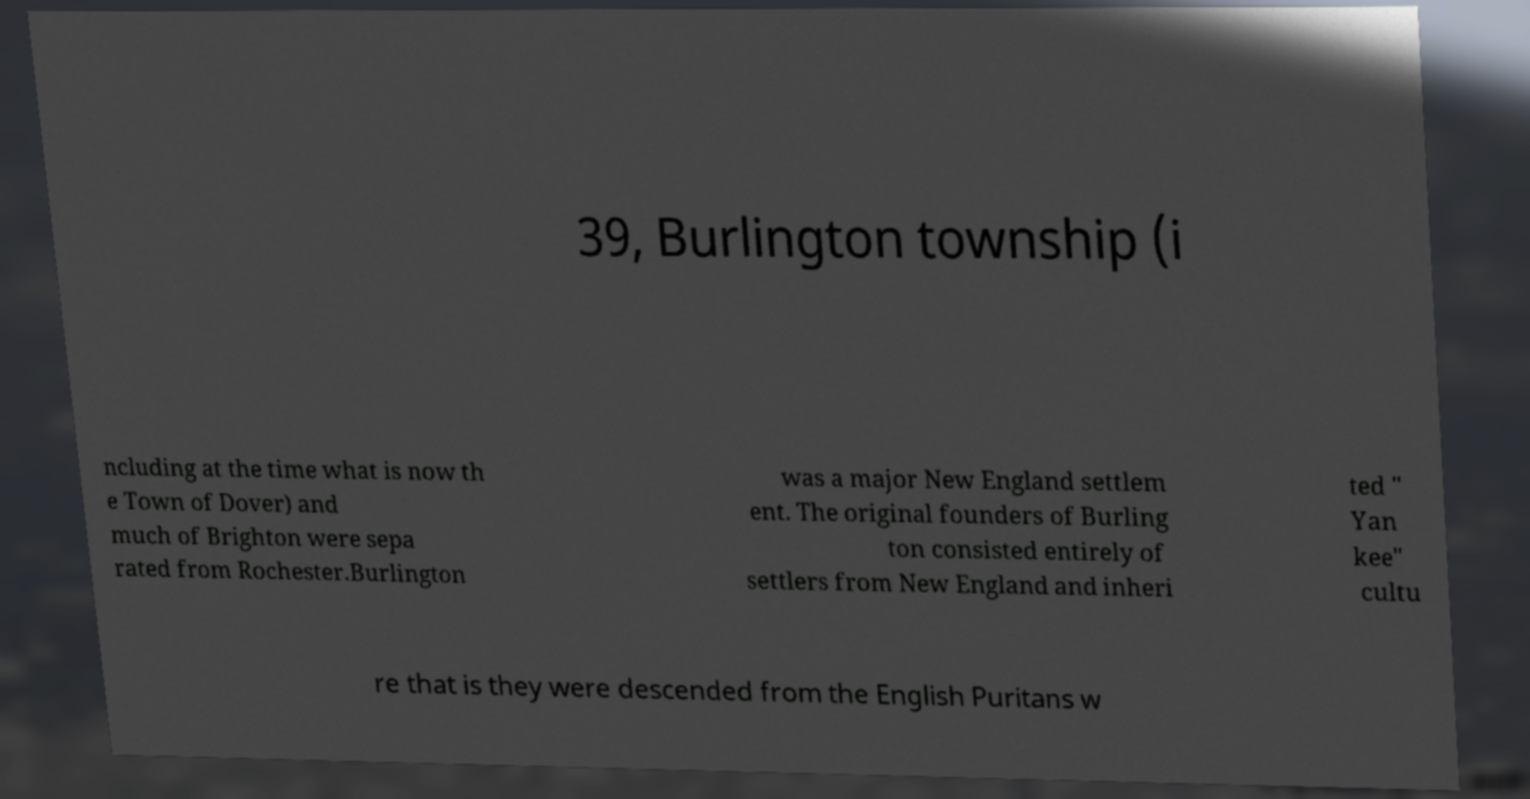Can you accurately transcribe the text from the provided image for me? 39, Burlington township (i ncluding at the time what is now th e Town of Dover) and much of Brighton were sepa rated from Rochester.Burlington was a major New England settlem ent. The original founders of Burling ton consisted entirely of settlers from New England and inheri ted " Yan kee" cultu re that is they were descended from the English Puritans w 